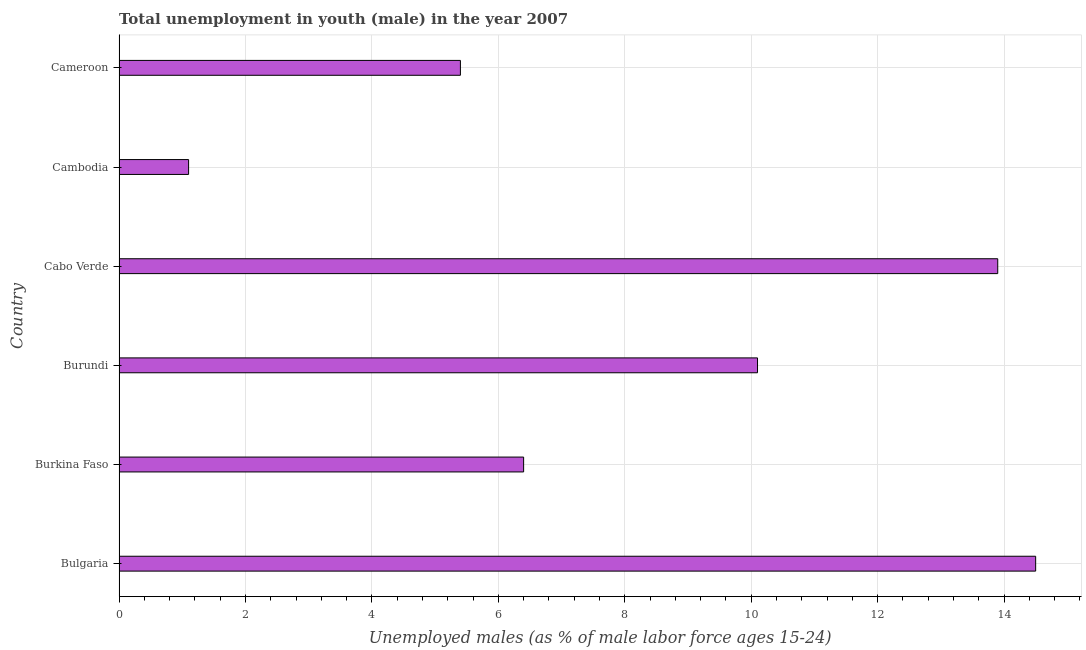What is the title of the graph?
Provide a succinct answer. Total unemployment in youth (male) in the year 2007. What is the label or title of the X-axis?
Offer a terse response. Unemployed males (as % of male labor force ages 15-24). What is the unemployed male youth population in Cambodia?
Provide a short and direct response. 1.1. Across all countries, what is the maximum unemployed male youth population?
Provide a short and direct response. 14.5. Across all countries, what is the minimum unemployed male youth population?
Your answer should be very brief. 1.1. In which country was the unemployed male youth population maximum?
Your answer should be compact. Bulgaria. In which country was the unemployed male youth population minimum?
Your answer should be very brief. Cambodia. What is the sum of the unemployed male youth population?
Provide a short and direct response. 51.4. What is the difference between the unemployed male youth population in Burundi and Cambodia?
Your answer should be very brief. 9. What is the average unemployed male youth population per country?
Offer a terse response. 8.57. What is the median unemployed male youth population?
Provide a short and direct response. 8.25. In how many countries, is the unemployed male youth population greater than 12.8 %?
Offer a terse response. 2. What is the ratio of the unemployed male youth population in Bulgaria to that in Burundi?
Provide a short and direct response. 1.44. Is the difference between the unemployed male youth population in Bulgaria and Cameroon greater than the difference between any two countries?
Ensure brevity in your answer.  No. What is the difference between the highest and the second highest unemployed male youth population?
Your response must be concise. 0.6. Is the sum of the unemployed male youth population in Cabo Verde and Cambodia greater than the maximum unemployed male youth population across all countries?
Provide a succinct answer. Yes. What is the difference between the highest and the lowest unemployed male youth population?
Keep it short and to the point. 13.4. In how many countries, is the unemployed male youth population greater than the average unemployed male youth population taken over all countries?
Offer a very short reply. 3. How many countries are there in the graph?
Provide a short and direct response. 6. What is the Unemployed males (as % of male labor force ages 15-24) in Burkina Faso?
Provide a succinct answer. 6.4. What is the Unemployed males (as % of male labor force ages 15-24) in Burundi?
Your response must be concise. 10.1. What is the Unemployed males (as % of male labor force ages 15-24) in Cabo Verde?
Offer a very short reply. 13.9. What is the Unemployed males (as % of male labor force ages 15-24) of Cambodia?
Give a very brief answer. 1.1. What is the Unemployed males (as % of male labor force ages 15-24) of Cameroon?
Give a very brief answer. 5.4. What is the difference between the Unemployed males (as % of male labor force ages 15-24) in Bulgaria and Burundi?
Provide a succinct answer. 4.4. What is the difference between the Unemployed males (as % of male labor force ages 15-24) in Bulgaria and Cambodia?
Your response must be concise. 13.4. What is the difference between the Unemployed males (as % of male labor force ages 15-24) in Bulgaria and Cameroon?
Give a very brief answer. 9.1. What is the difference between the Unemployed males (as % of male labor force ages 15-24) in Burkina Faso and Burundi?
Your answer should be very brief. -3.7. What is the difference between the Unemployed males (as % of male labor force ages 15-24) in Burkina Faso and Cambodia?
Your answer should be compact. 5.3. What is the difference between the Unemployed males (as % of male labor force ages 15-24) in Burundi and Cabo Verde?
Your answer should be compact. -3.8. What is the difference between the Unemployed males (as % of male labor force ages 15-24) in Burundi and Cambodia?
Give a very brief answer. 9. What is the difference between the Unemployed males (as % of male labor force ages 15-24) in Cambodia and Cameroon?
Give a very brief answer. -4.3. What is the ratio of the Unemployed males (as % of male labor force ages 15-24) in Bulgaria to that in Burkina Faso?
Provide a succinct answer. 2.27. What is the ratio of the Unemployed males (as % of male labor force ages 15-24) in Bulgaria to that in Burundi?
Provide a succinct answer. 1.44. What is the ratio of the Unemployed males (as % of male labor force ages 15-24) in Bulgaria to that in Cabo Verde?
Ensure brevity in your answer.  1.04. What is the ratio of the Unemployed males (as % of male labor force ages 15-24) in Bulgaria to that in Cambodia?
Offer a terse response. 13.18. What is the ratio of the Unemployed males (as % of male labor force ages 15-24) in Bulgaria to that in Cameroon?
Your answer should be compact. 2.69. What is the ratio of the Unemployed males (as % of male labor force ages 15-24) in Burkina Faso to that in Burundi?
Make the answer very short. 0.63. What is the ratio of the Unemployed males (as % of male labor force ages 15-24) in Burkina Faso to that in Cabo Verde?
Your answer should be compact. 0.46. What is the ratio of the Unemployed males (as % of male labor force ages 15-24) in Burkina Faso to that in Cambodia?
Provide a short and direct response. 5.82. What is the ratio of the Unemployed males (as % of male labor force ages 15-24) in Burkina Faso to that in Cameroon?
Offer a terse response. 1.19. What is the ratio of the Unemployed males (as % of male labor force ages 15-24) in Burundi to that in Cabo Verde?
Keep it short and to the point. 0.73. What is the ratio of the Unemployed males (as % of male labor force ages 15-24) in Burundi to that in Cambodia?
Give a very brief answer. 9.18. What is the ratio of the Unemployed males (as % of male labor force ages 15-24) in Burundi to that in Cameroon?
Provide a succinct answer. 1.87. What is the ratio of the Unemployed males (as % of male labor force ages 15-24) in Cabo Verde to that in Cambodia?
Your answer should be very brief. 12.64. What is the ratio of the Unemployed males (as % of male labor force ages 15-24) in Cabo Verde to that in Cameroon?
Ensure brevity in your answer.  2.57. What is the ratio of the Unemployed males (as % of male labor force ages 15-24) in Cambodia to that in Cameroon?
Provide a succinct answer. 0.2. 